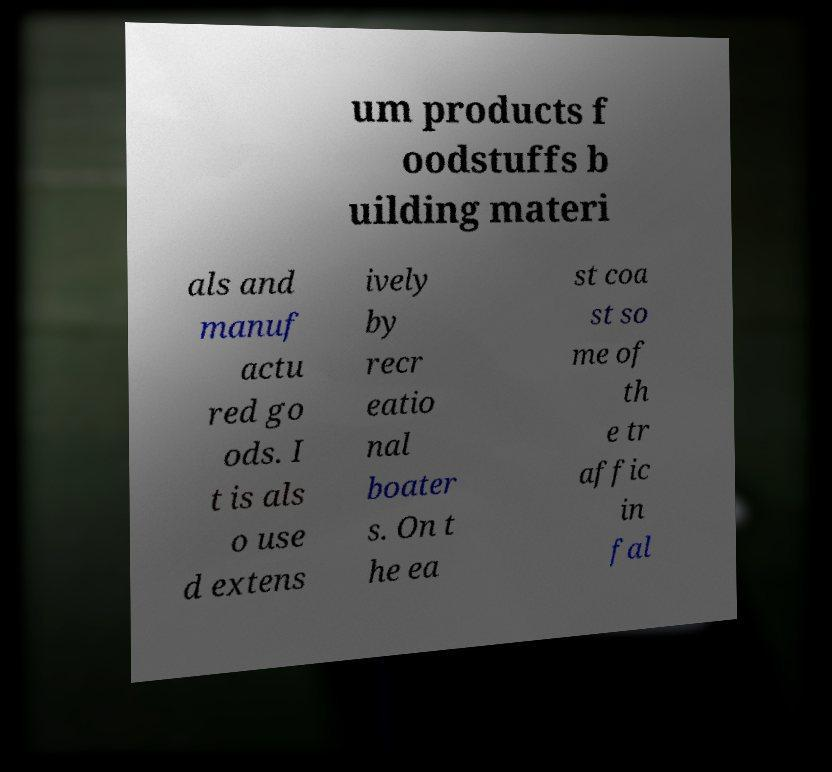I need the written content from this picture converted into text. Can you do that? um products f oodstuffs b uilding materi als and manuf actu red go ods. I t is als o use d extens ively by recr eatio nal boater s. On t he ea st coa st so me of th e tr affic in fal 